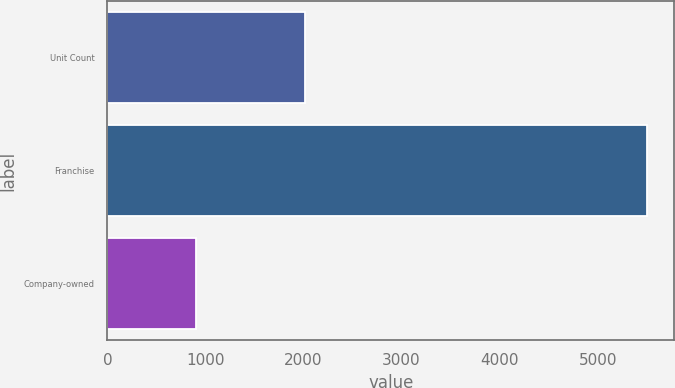Convert chart to OTSL. <chart><loc_0><loc_0><loc_500><loc_500><bar_chart><fcel>Unit Count<fcel>Franchise<fcel>Company-owned<nl><fcel>2015<fcel>5507<fcel>900<nl></chart> 